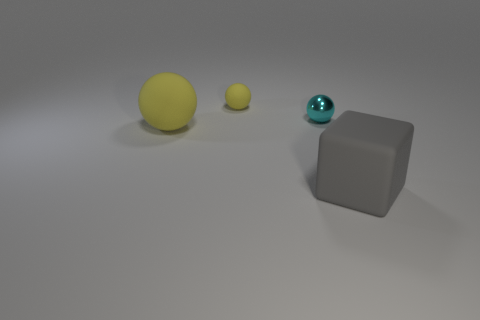Can you tell me what objects are present in this image and describe them? Certainly! The image shows three objects on a flat surface with a muted background. Starting from the left, there's a larger yellow sphere, a smaller cyan sphere, and a matte gray cube on the right. The spheres have a smooth texture, while the cube displays a matte finish. There's soft lighting that casts gentle shadows beneath the objects. 